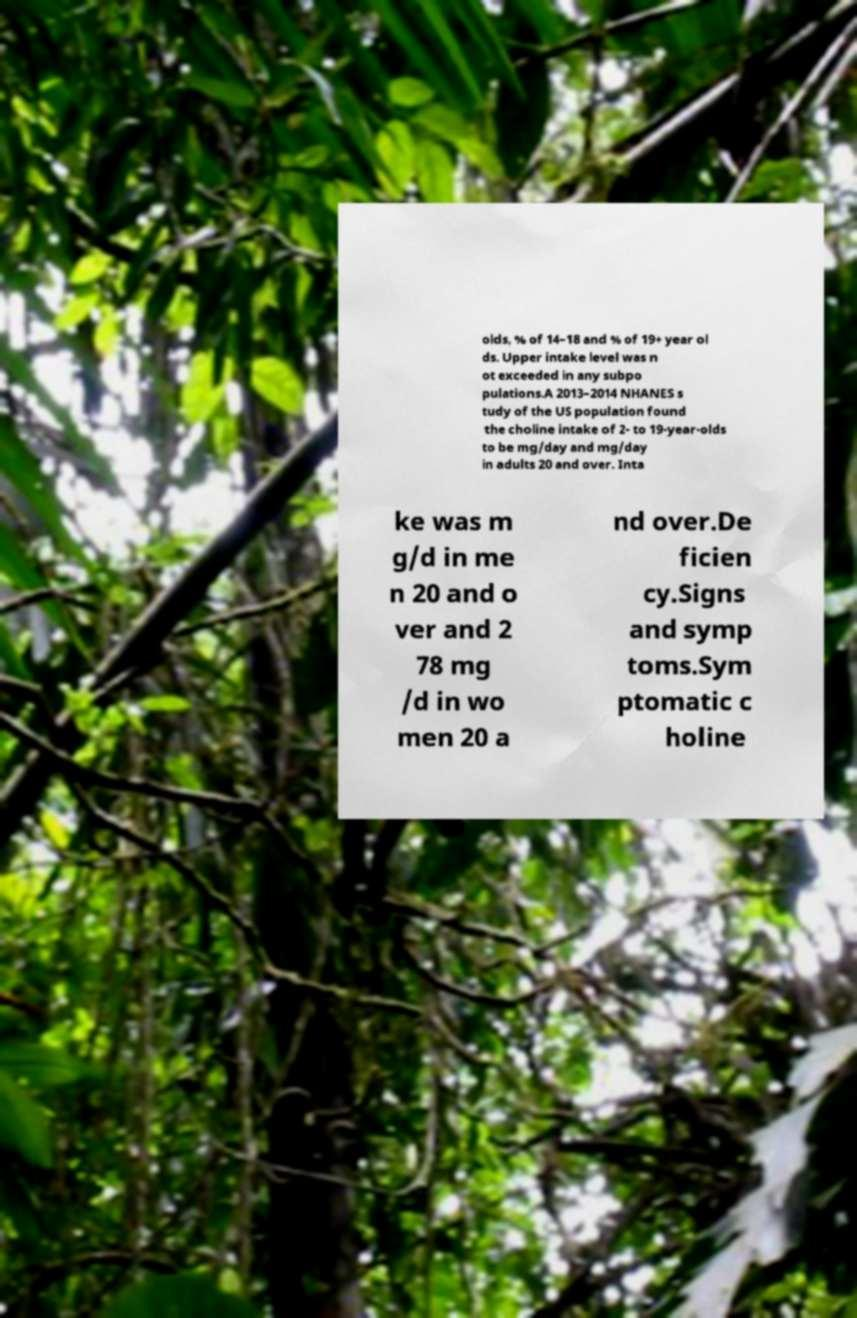Can you read and provide the text displayed in the image?This photo seems to have some interesting text. Can you extract and type it out for me? olds, % of 14–18 and % of 19+ year ol ds. Upper intake level was n ot exceeded in any subpo pulations.A 2013–2014 NHANES s tudy of the US population found the choline intake of 2- to 19-year-olds to be mg/day and mg/day in adults 20 and over. Inta ke was m g/d in me n 20 and o ver and 2 78 mg /d in wo men 20 a nd over.De ficien cy.Signs and symp toms.Sym ptomatic c holine 